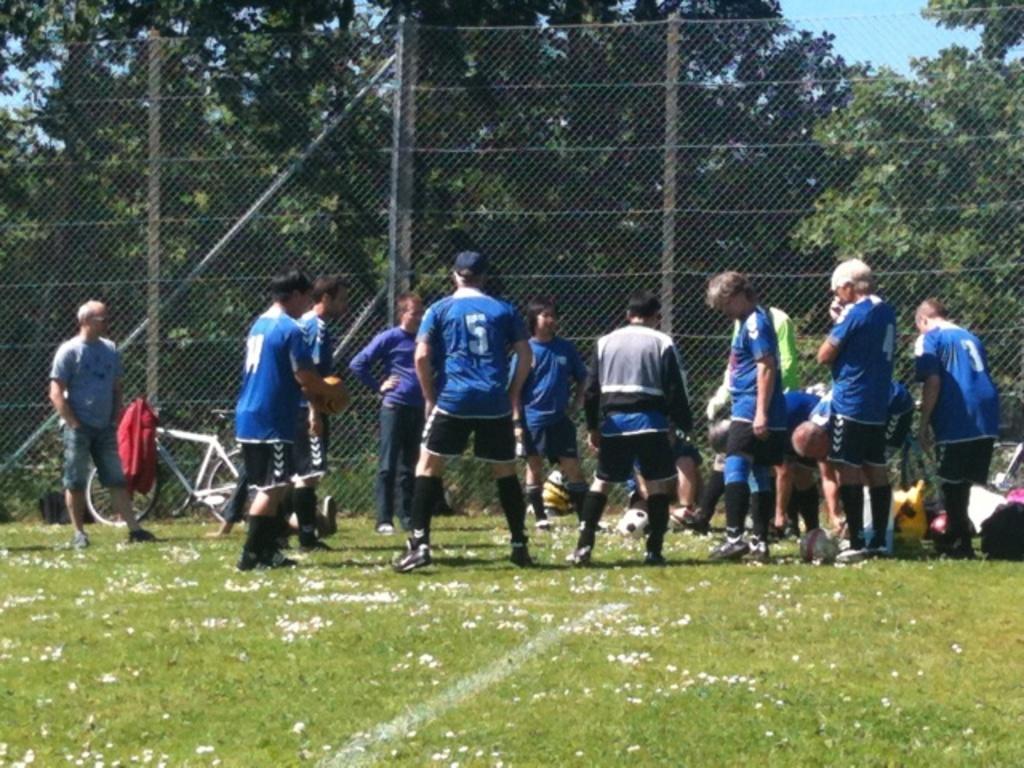Please provide a concise description of this image. In this picture we can see a few people on the grass. There are some white flowers and a few objects on the grass. We can see a red jacket on a bicycle. There is some fencing, poles and a few trees in the background. Sky is blue in color. 